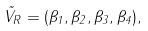<formula> <loc_0><loc_0><loc_500><loc_500>\vec { V } _ { R } = ( \beta _ { 1 } , \beta _ { 2 } , \beta _ { 3 } , \beta _ { 4 } ) ,</formula> 